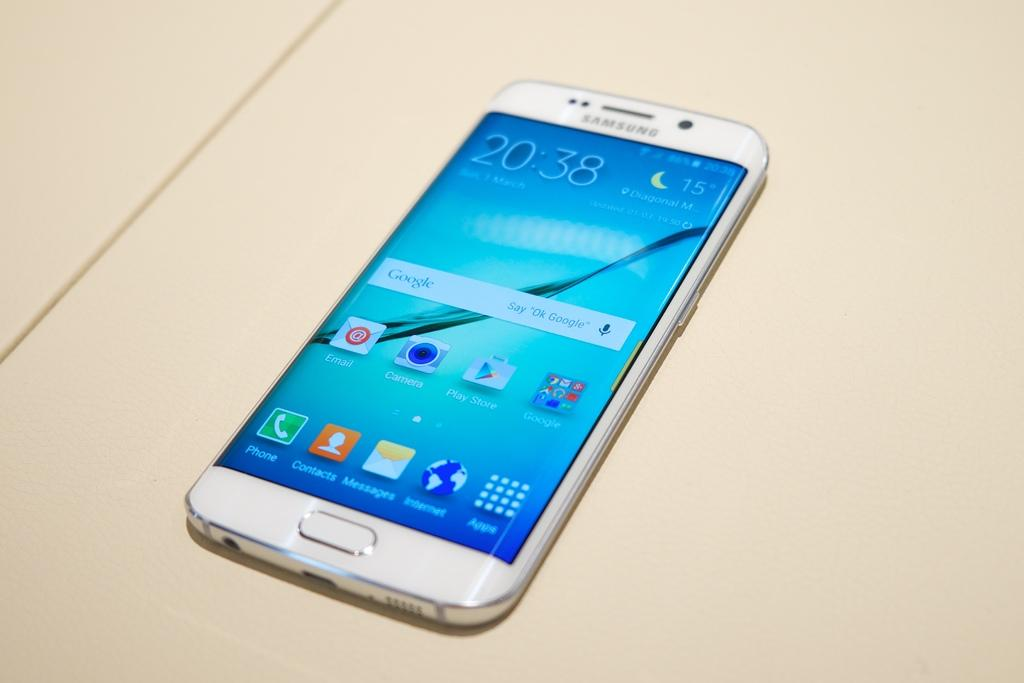<image>
Describe the image concisely. The time on the white cell phone is 20:38 